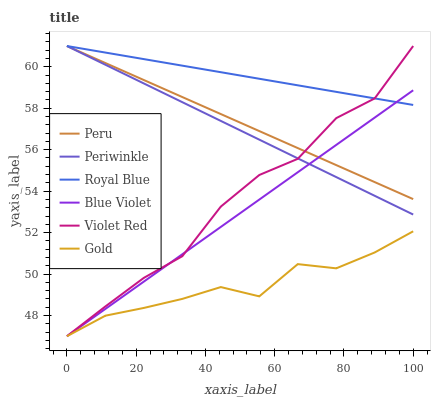Does Royal Blue have the minimum area under the curve?
Answer yes or no. No. Does Gold have the maximum area under the curve?
Answer yes or no. No. Is Gold the smoothest?
Answer yes or no. No. Is Gold the roughest?
Answer yes or no. No. Does Royal Blue have the lowest value?
Answer yes or no. No. Does Gold have the highest value?
Answer yes or no. No. Is Gold less than Periwinkle?
Answer yes or no. Yes. Is Peru greater than Gold?
Answer yes or no. Yes. Does Gold intersect Periwinkle?
Answer yes or no. No. 